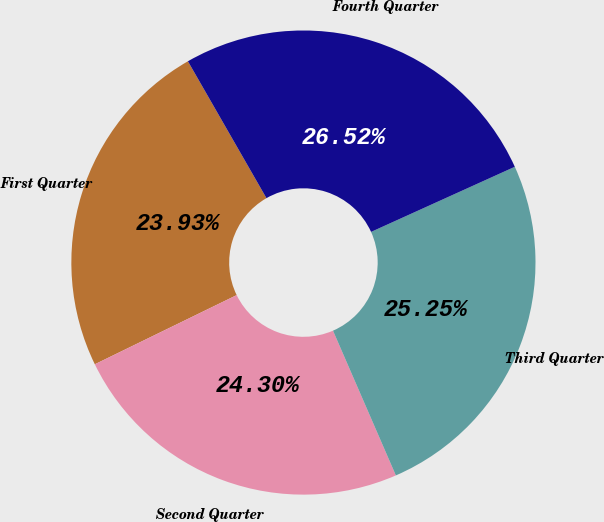Convert chart. <chart><loc_0><loc_0><loc_500><loc_500><pie_chart><fcel>First Quarter<fcel>Second Quarter<fcel>Third Quarter<fcel>Fourth Quarter<nl><fcel>23.93%<fcel>24.3%<fcel>25.25%<fcel>26.52%<nl></chart> 